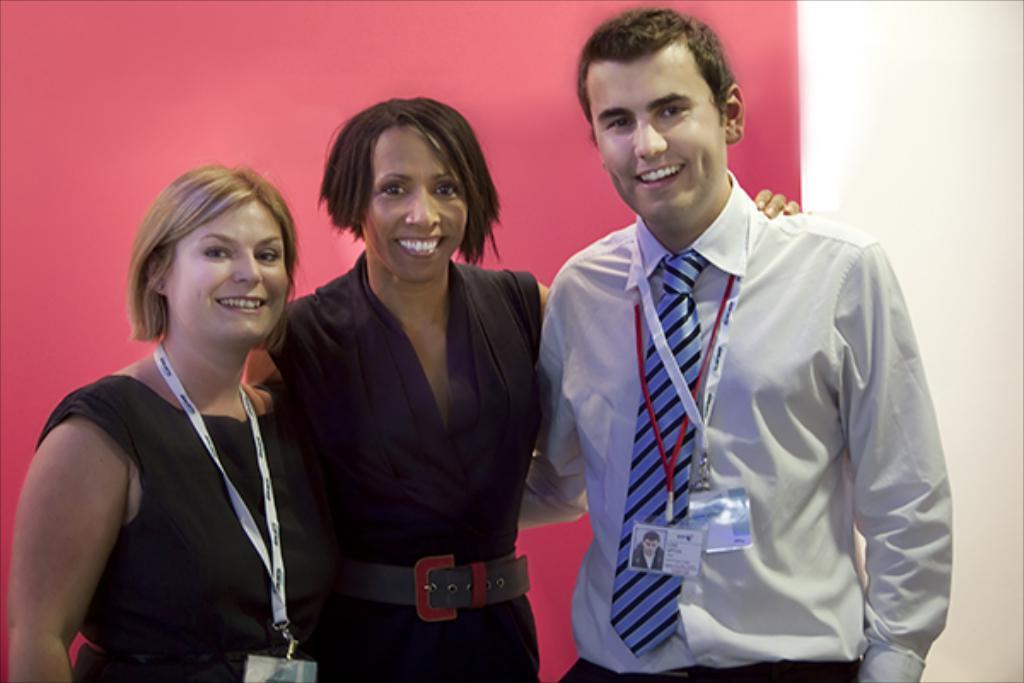Describe this image in one or two sentences. In this image I can see a man and two women are standing. I can see smile on their faces. On the right side of this image I can see he is wearing shirt, tie and on the left side I can see these two are wearing black color dress. I can also see two of them are wearing ID cards. I can also see red color wall in the background. 